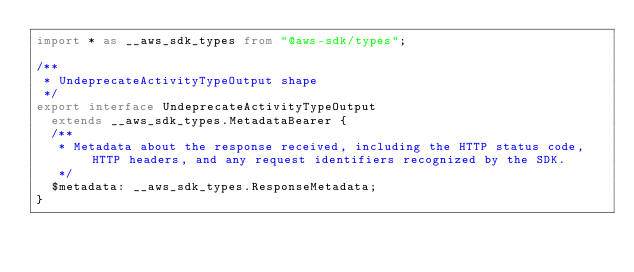<code> <loc_0><loc_0><loc_500><loc_500><_TypeScript_>import * as __aws_sdk_types from "@aws-sdk/types";

/**
 * UndeprecateActivityTypeOutput shape
 */
export interface UndeprecateActivityTypeOutput
  extends __aws_sdk_types.MetadataBearer {
  /**
   * Metadata about the response received, including the HTTP status code, HTTP headers, and any request identifiers recognized by the SDK.
   */
  $metadata: __aws_sdk_types.ResponseMetadata;
}
</code> 